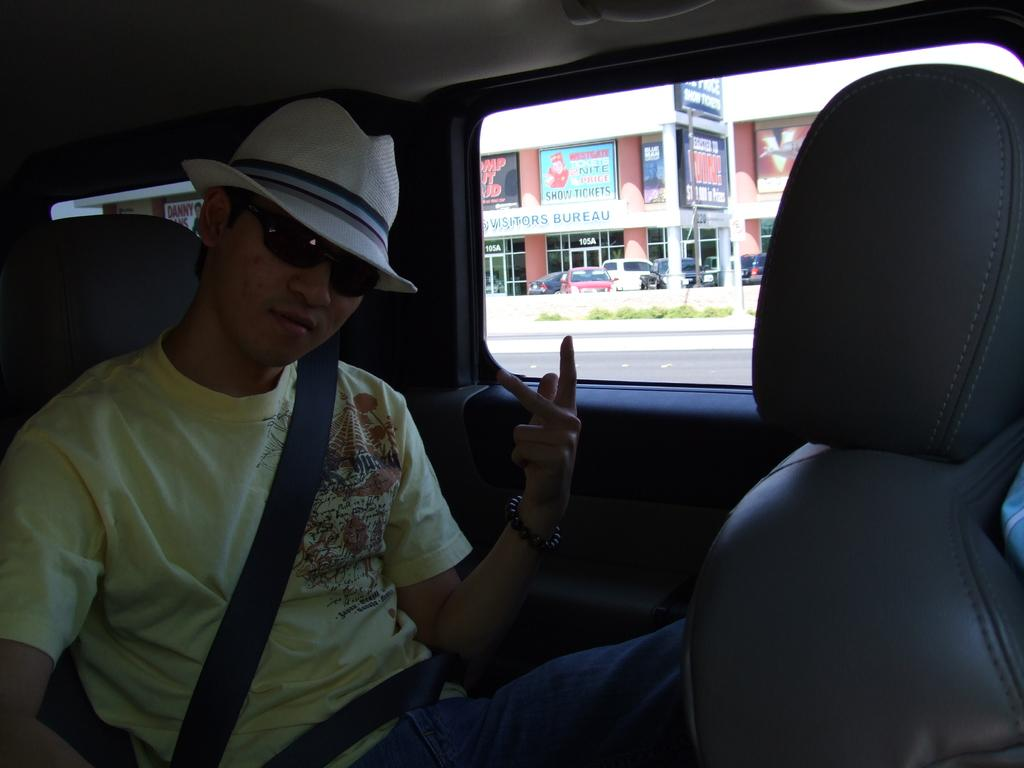What is the man in the image doing? A: The man is sitting on a vehicle. What safety precaution is the man taking in the image? The man is wearing a seat belt. What protective gear is the man wearing in the image? The man is wearing goggles. What type of headwear is the man wearing in the image? The man is wearing a cap. What can be seen through the window in the image? A banner, a building, a door, cars, grass, and a road can be seen through the window. What design does the beginner use to support the structure in the image? There is no structure or design mentioned in the image, and the term "beginner" is not relevant to the image. 